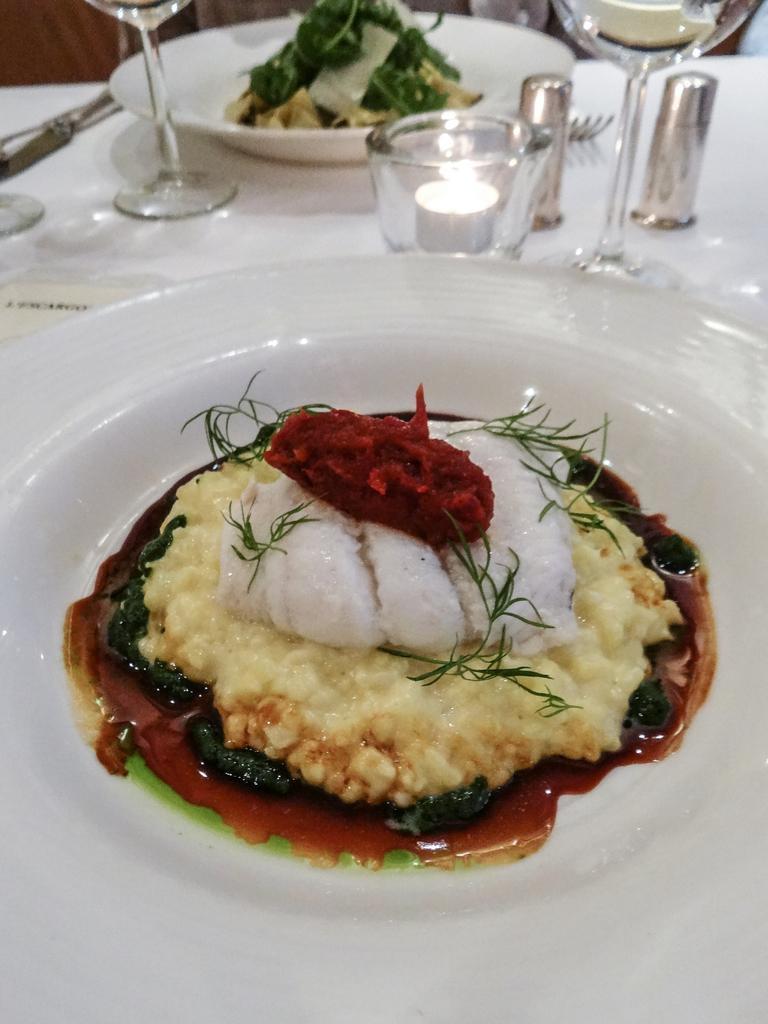Could you give a brief overview of what you see in this image? We can see plates,food,glasses and objects on the table. 